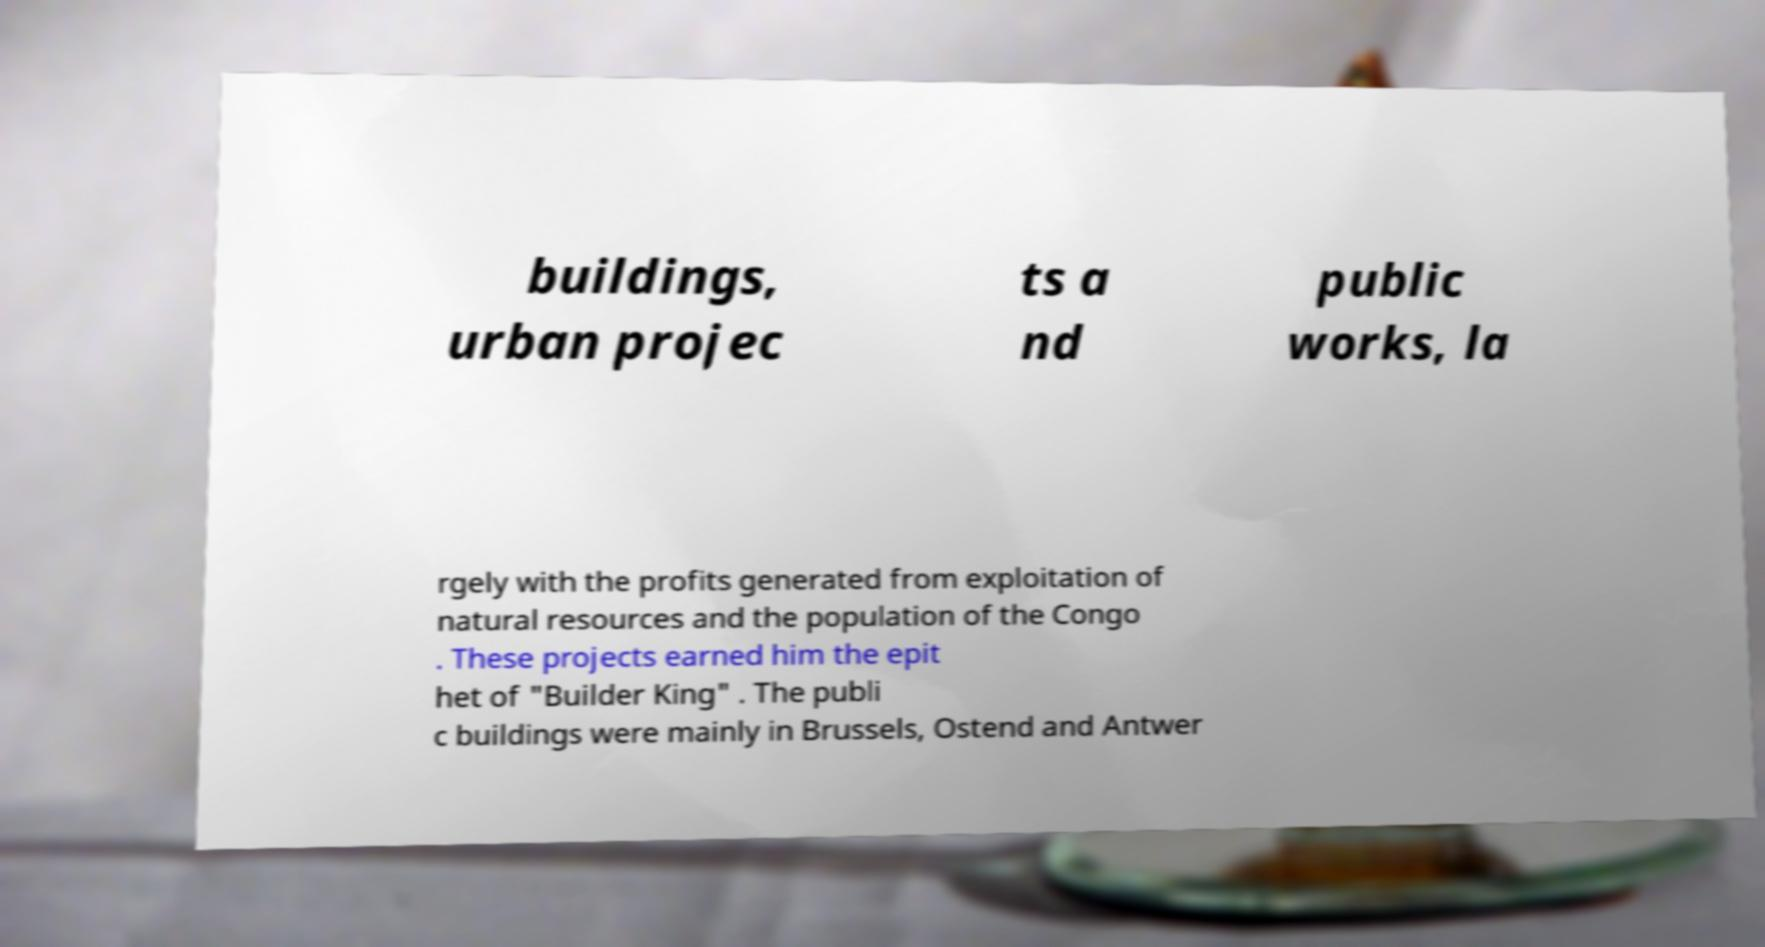Can you read and provide the text displayed in the image?This photo seems to have some interesting text. Can you extract and type it out for me? buildings, urban projec ts a nd public works, la rgely with the profits generated from exploitation of natural resources and the population of the Congo . These projects earned him the epit het of "Builder King" . The publi c buildings were mainly in Brussels, Ostend and Antwer 